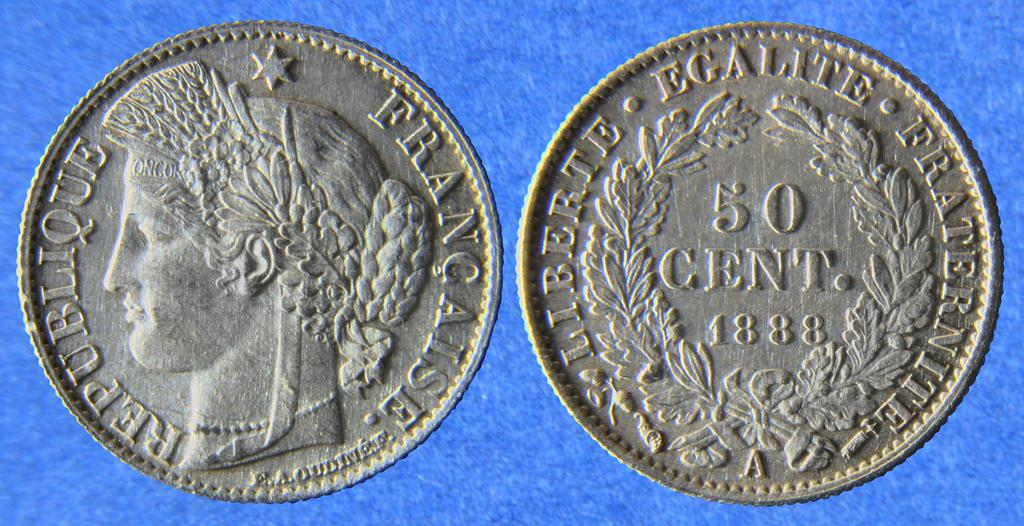<image>
Provide a brief description of the given image. A coin from france that is a 50 cent piece from 1888. 